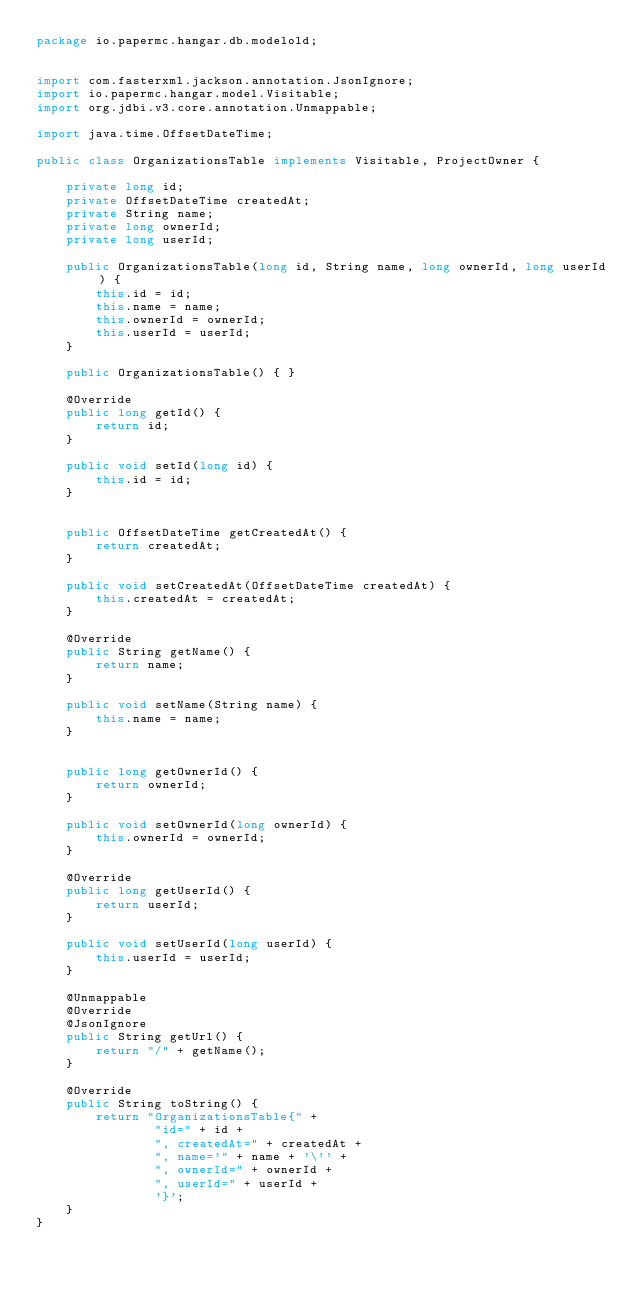Convert code to text. <code><loc_0><loc_0><loc_500><loc_500><_Java_>package io.papermc.hangar.db.modelold;


import com.fasterxml.jackson.annotation.JsonIgnore;
import io.papermc.hangar.model.Visitable;
import org.jdbi.v3.core.annotation.Unmappable;

import java.time.OffsetDateTime;

public class OrganizationsTable implements Visitable, ProjectOwner {

    private long id;
    private OffsetDateTime createdAt;
    private String name;
    private long ownerId;
    private long userId;

    public OrganizationsTable(long id, String name, long ownerId, long userId) {
        this.id = id;
        this.name = name;
        this.ownerId = ownerId;
        this.userId = userId;
    }

    public OrganizationsTable() { }

    @Override
    public long getId() {
        return id;
    }

    public void setId(long id) {
        this.id = id;
    }


    public OffsetDateTime getCreatedAt() {
        return createdAt;
    }

    public void setCreatedAt(OffsetDateTime createdAt) {
        this.createdAt = createdAt;
    }

    @Override
    public String getName() {
        return name;
    }

    public void setName(String name) {
        this.name = name;
    }


    public long getOwnerId() {
        return ownerId;
    }

    public void setOwnerId(long ownerId) {
        this.ownerId = ownerId;
    }

    @Override
    public long getUserId() {
        return userId;
    }

    public void setUserId(long userId) {
        this.userId = userId;
    }

    @Unmappable
    @Override
    @JsonIgnore
    public String getUrl() {
        return "/" + getName();
    }

    @Override
    public String toString() {
        return "OrganizationsTable{" +
                "id=" + id +
                ", createdAt=" + createdAt +
                ", name='" + name + '\'' +
                ", ownerId=" + ownerId +
                ", userId=" + userId +
                '}';
    }
}
</code> 